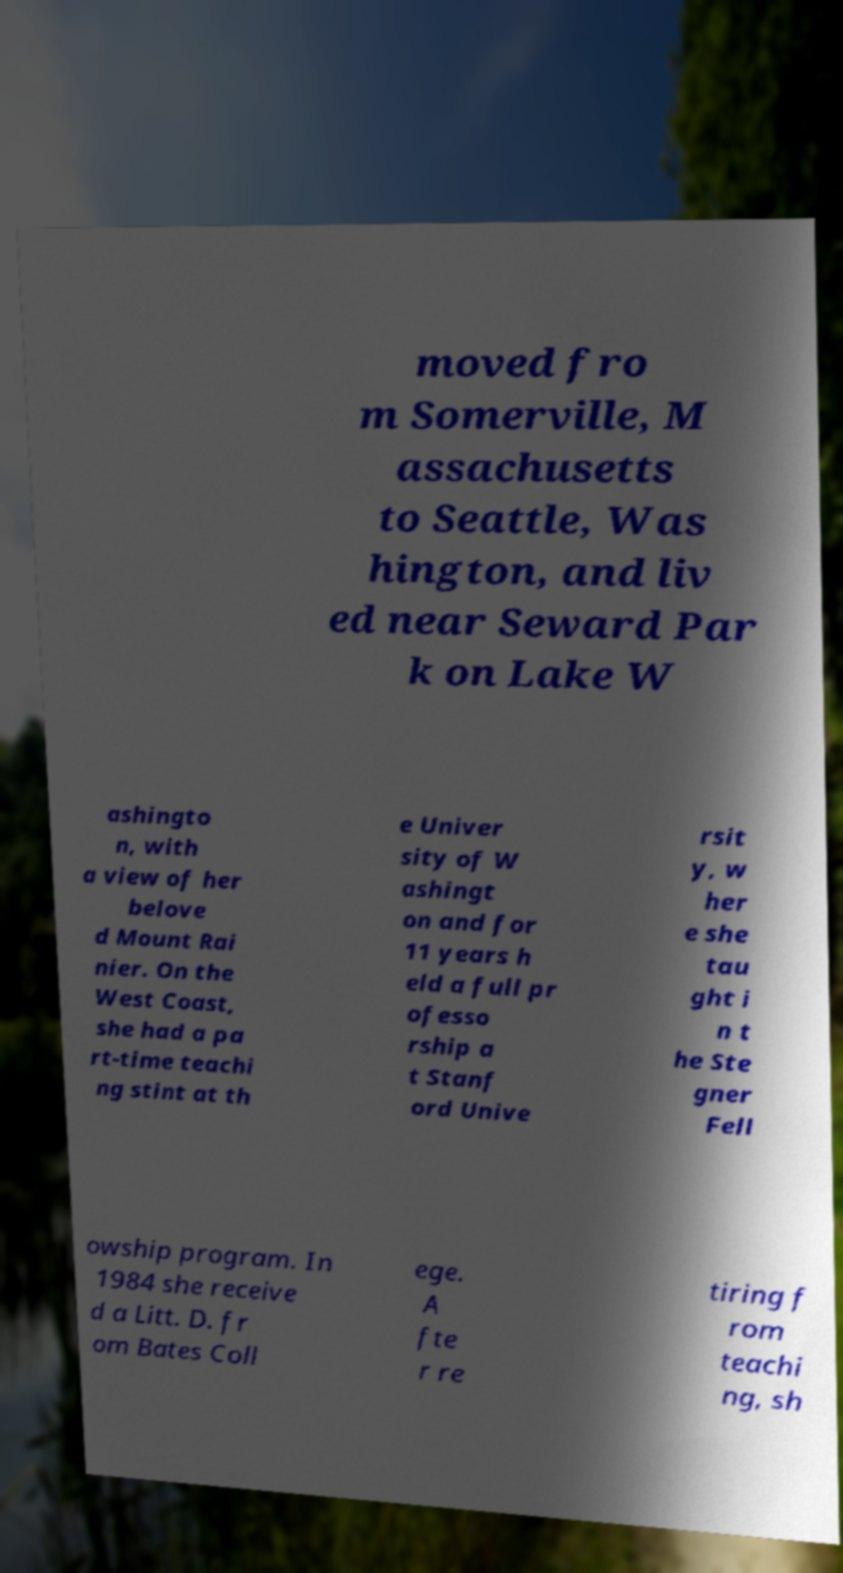Could you assist in decoding the text presented in this image and type it out clearly? moved fro m Somerville, M assachusetts to Seattle, Was hington, and liv ed near Seward Par k on Lake W ashingto n, with a view of her belove d Mount Rai nier. On the West Coast, she had a pa rt-time teachi ng stint at th e Univer sity of W ashingt on and for 11 years h eld a full pr ofesso rship a t Stanf ord Unive rsit y, w her e she tau ght i n t he Ste gner Fell owship program. In 1984 she receive d a Litt. D. fr om Bates Coll ege. A fte r re tiring f rom teachi ng, sh 